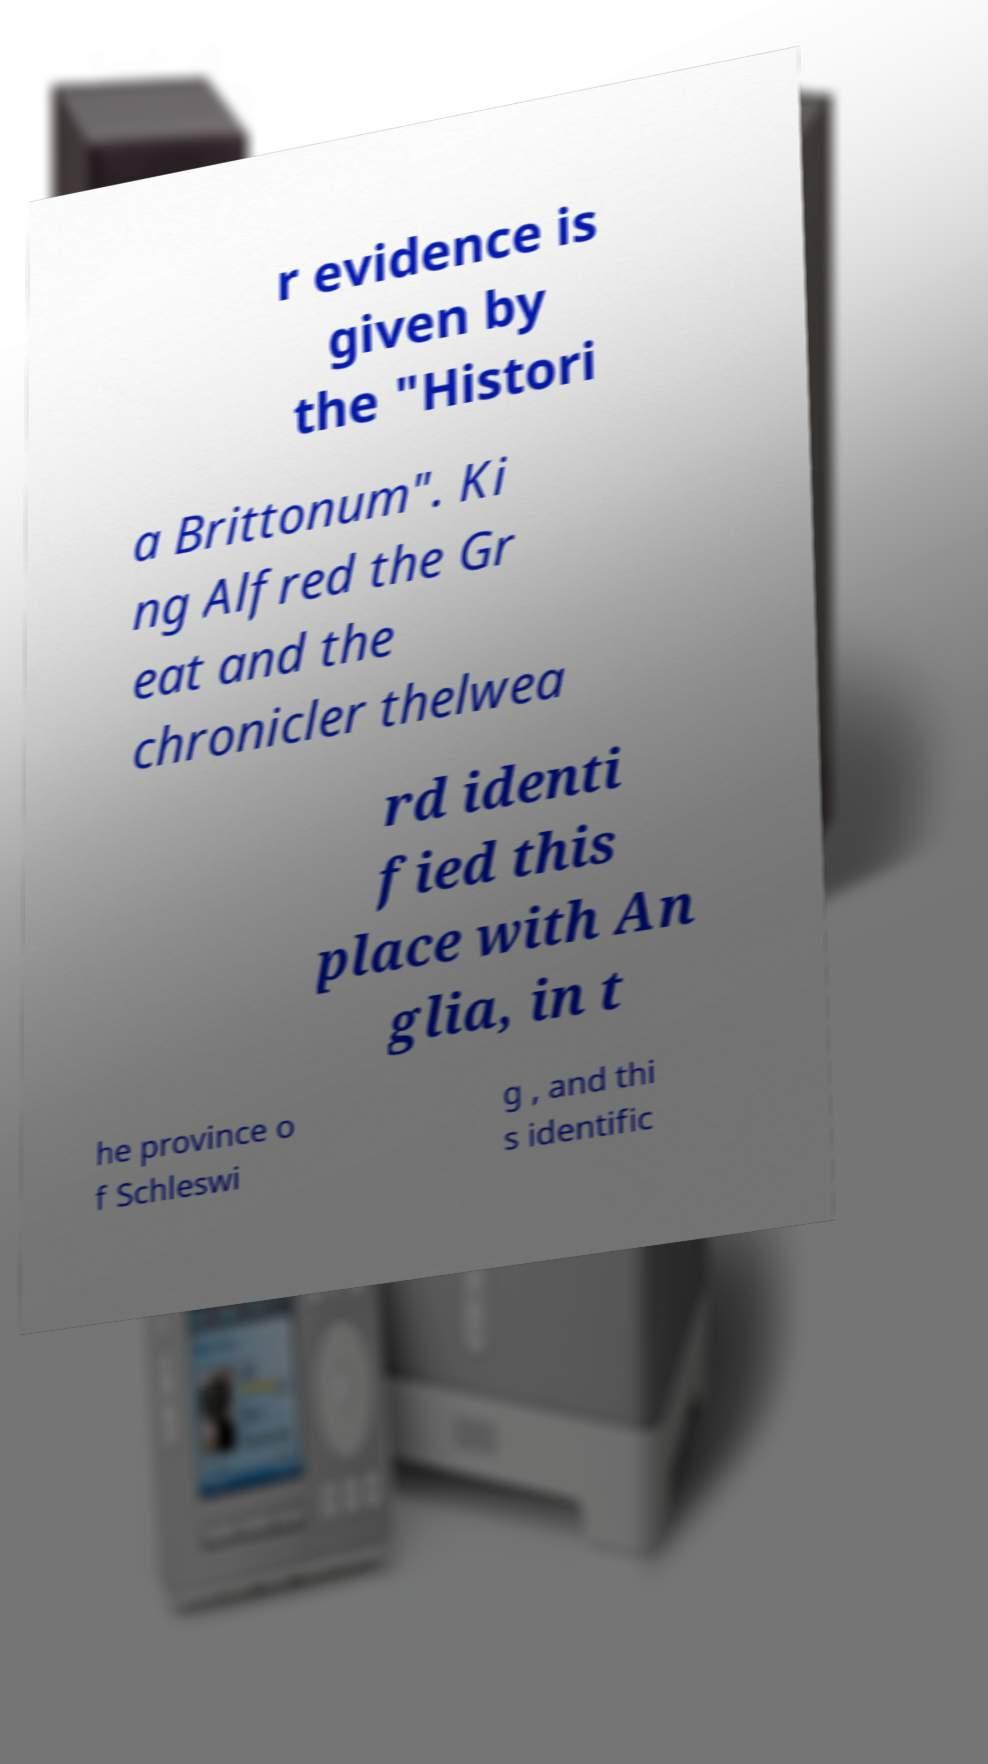Can you accurately transcribe the text from the provided image for me? r evidence is given by the "Histori a Brittonum". Ki ng Alfred the Gr eat and the chronicler thelwea rd identi fied this place with An glia, in t he province o f Schleswi g , and thi s identific 